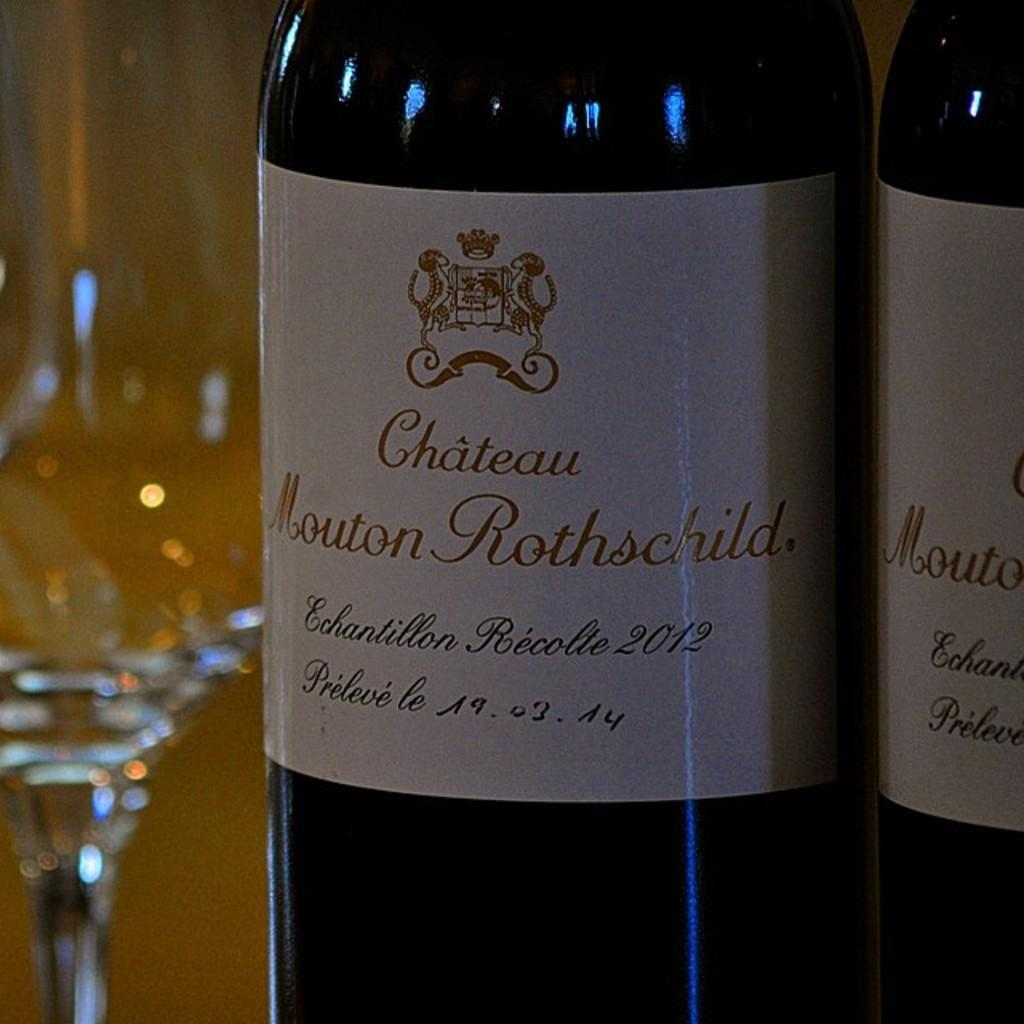<image>
Give a short and clear explanation of the subsequent image. A bottle of Chateau Mouton Rothschild is placed next to an empty glass. 